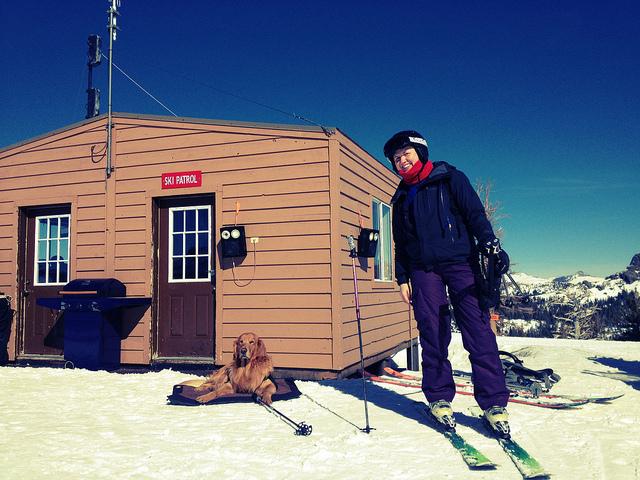What does the sign above the door read?
Be succinct. Ski patrol. What color are the mans skis?
Short answer required. Green. What kind of pants is the woman wearing?
Write a very short answer. Ski. What is the man doing?
Give a very brief answer. Skiing. Are all these people flying kites?
Be succinct. No. What is this animal doing?
Short answer required. Laying down. What is under the woman's left arm?
Give a very brief answer. Nothing. 